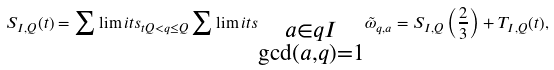Convert formula to latex. <formula><loc_0><loc_0><loc_500><loc_500>S _ { I , Q } ( t ) = \sum \lim i t s _ { t Q < q \leq Q } \sum \lim i t s _ { \substack { a \in q I \\ \gcd ( a , q ) = 1 } } \tilde { \omega } _ { q , a } = S _ { I , Q } \left ( \frac { 2 } { 3 } \right ) + T _ { I , Q } ( t ) ,</formula> 